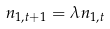<formula> <loc_0><loc_0><loc_500><loc_500>n _ { 1 , t + 1 } = \lambda n _ { 1 , t }</formula> 